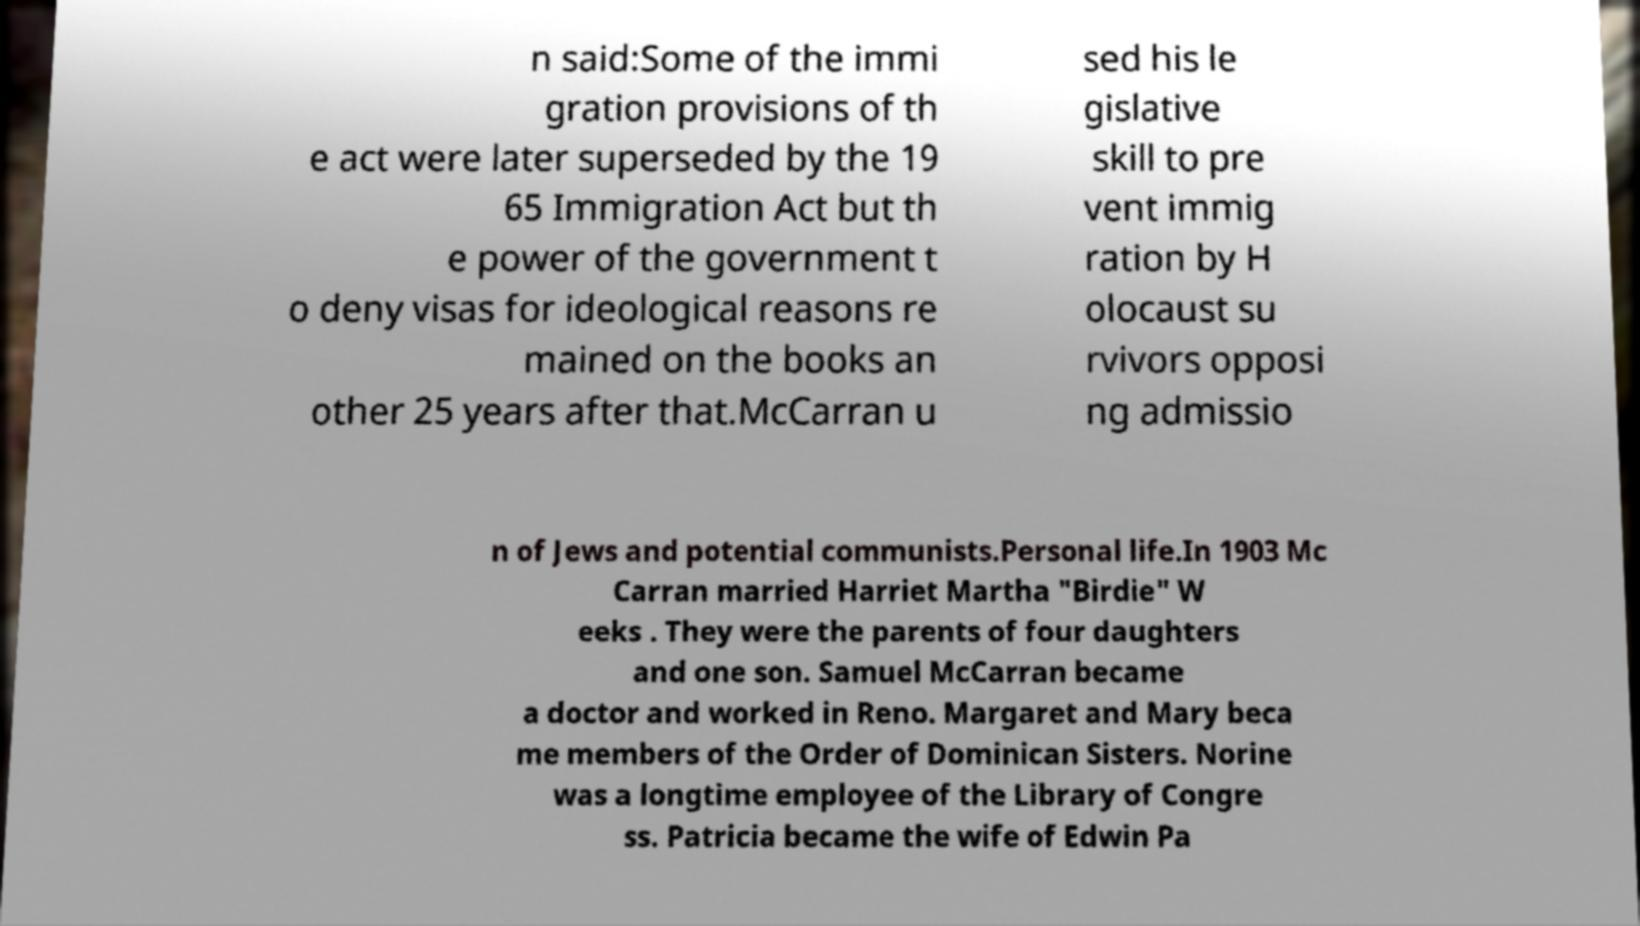I need the written content from this picture converted into text. Can you do that? n said:Some of the immi gration provisions of th e act were later superseded by the 19 65 Immigration Act but th e power of the government t o deny visas for ideological reasons re mained on the books an other 25 years after that.McCarran u sed his le gislative skill to pre vent immig ration by H olocaust su rvivors opposi ng admissio n of Jews and potential communists.Personal life.In 1903 Mc Carran married Harriet Martha "Birdie" W eeks . They were the parents of four daughters and one son. Samuel McCarran became a doctor and worked in Reno. Margaret and Mary beca me members of the Order of Dominican Sisters. Norine was a longtime employee of the Library of Congre ss. Patricia became the wife of Edwin Pa 